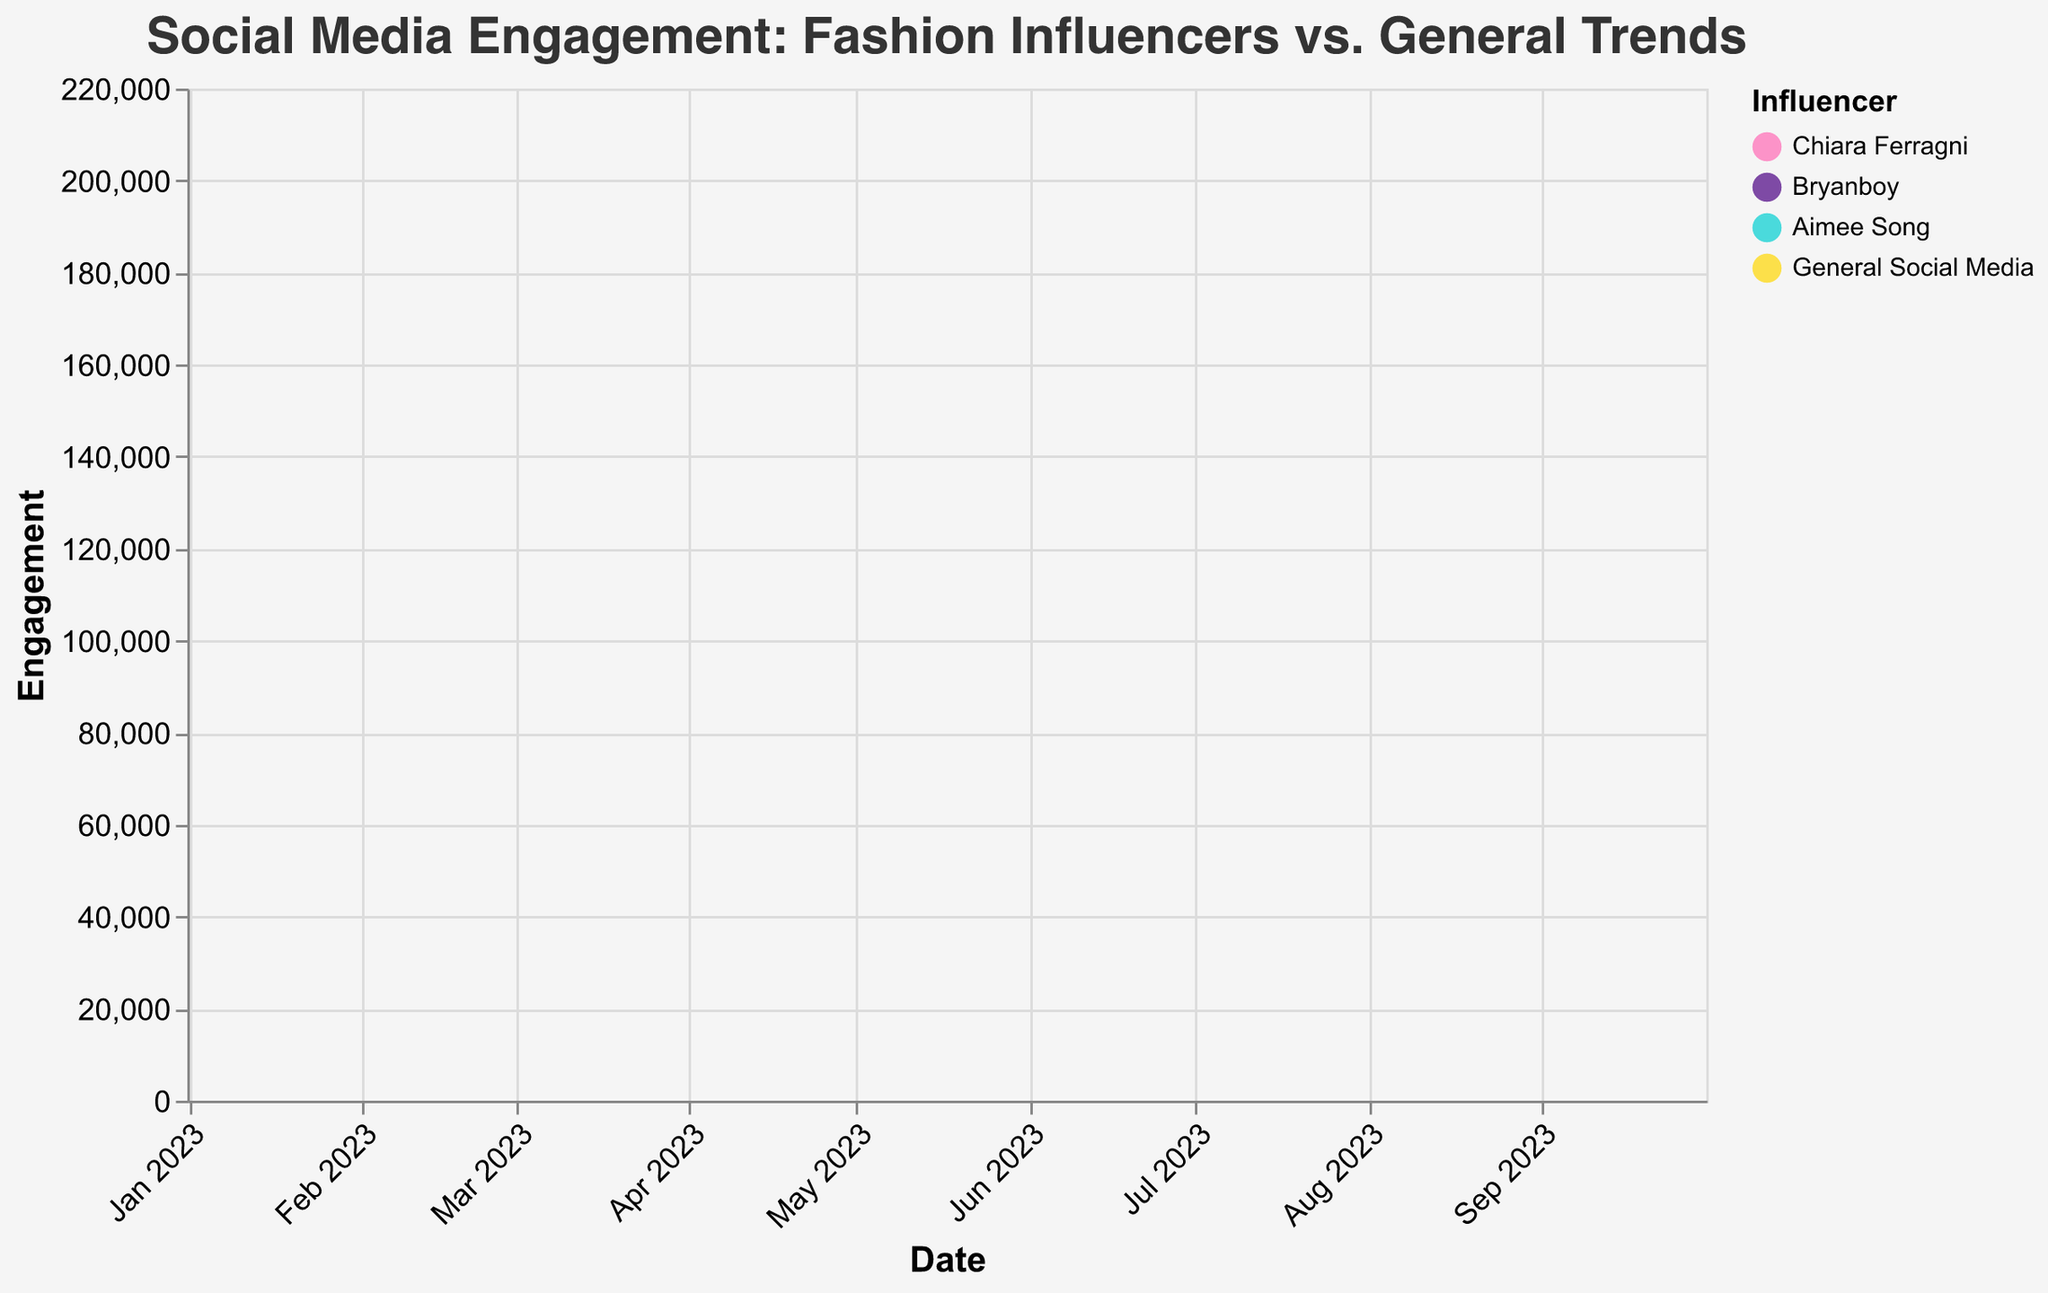What is the title of the chart? The title is displayed at the top center of the chart, usually in a larger and bolder font compared to other text elements.
Answer: Social Media Engagement: Fashion Influencers vs. General Trends Which influencer had the highest engagement in October 2023? Look at the y-axis values for each step area in October 2023 and identify the highest point
Answer: Chiara Ferragni Considering the entire time span from January to October 2023, which influencer experienced the greatest overall increase in engagement? Calculate the difference in engagement from January to October 2023 for each influencer. Chiara Ferragni's engagement increased from 10,000 to 15,000, Bryanboy from 8,000 to 9,000, and Aimee Song from 9,000 to 11,000. Compare these increases.
Answer: Chiara Ferragni How does General Social Media Use compare to the engagement of individual fashion influencers in January 2023? Compare the y-axis values of General Social Media Use and the engagement values of each influencer for January 2023. General Social Media Use is 150,000, which is significantly higher than individual influencers, whose engagements range from 8,000 to 10,000.
Answer: General Social Media Use is much higher What trend can you observe about social media engagement for Chiara Ferragni from January to October 2023? Observe the progression of Chiara Ferragni's engagement over time by following the pink area on the chart. Her engagement consistently increases.
Answer: Consistently increasing Between Bryanboy and Aimee Song, who had a higher engagement in July 2023? Compare the values on the y-axis for Bryanboy and Aimee Song in July 2023. Bryanboy had 8,700 and Aimee Song had 10,400.
Answer: Aimee Song What is the average engagement for Aimee Song over the displayed period? Sum the engagement values for Aimee Song from January to October 2023 and then divide by the number of months (10). (9000+9500+9600+9800+10000+10200+10400+10600+10800+11000) = 99900; 99900 / 10 = 9990
Answer: 9990 Describe the color scheme used for this chart to represent different influencers. Identify the colors assigned to each influencer by looking at the legend. Chiara Ferragni is represented in pink, Bryanboy in dark purple/blue, Aimee Song in cyan, and General Social Media is in yellow.
Answer: Chiara Ferragni in pink, Bryanboy in purple/blue, Aimee Song in cyan, General in yellow 